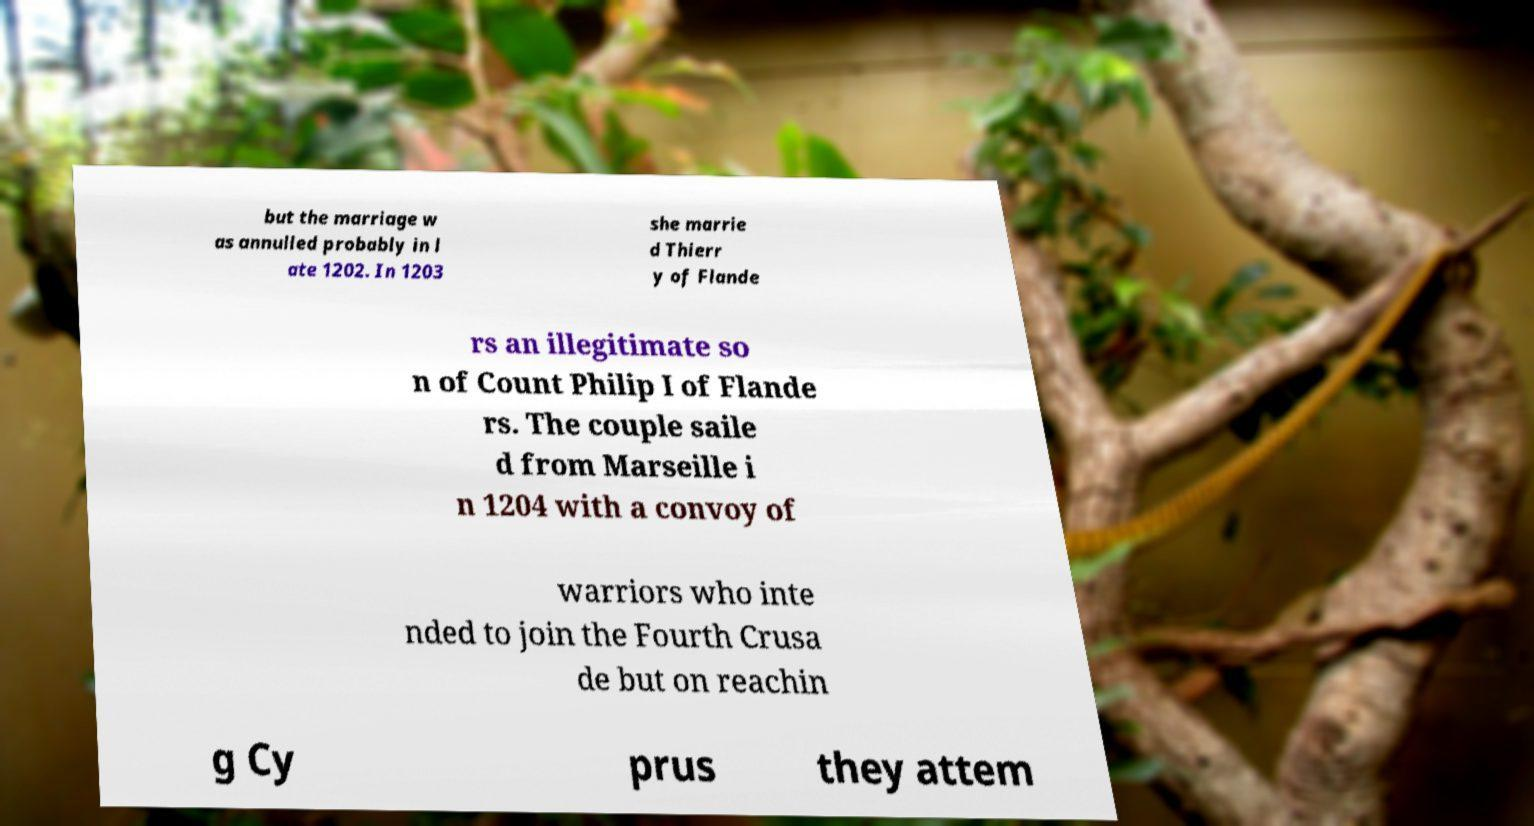Please identify and transcribe the text found in this image. but the marriage w as annulled probably in l ate 1202. In 1203 she marrie d Thierr y of Flande rs an illegitimate so n of Count Philip I of Flande rs. The couple saile d from Marseille i n 1204 with a convoy of warriors who inte nded to join the Fourth Crusa de but on reachin g Cy prus they attem 